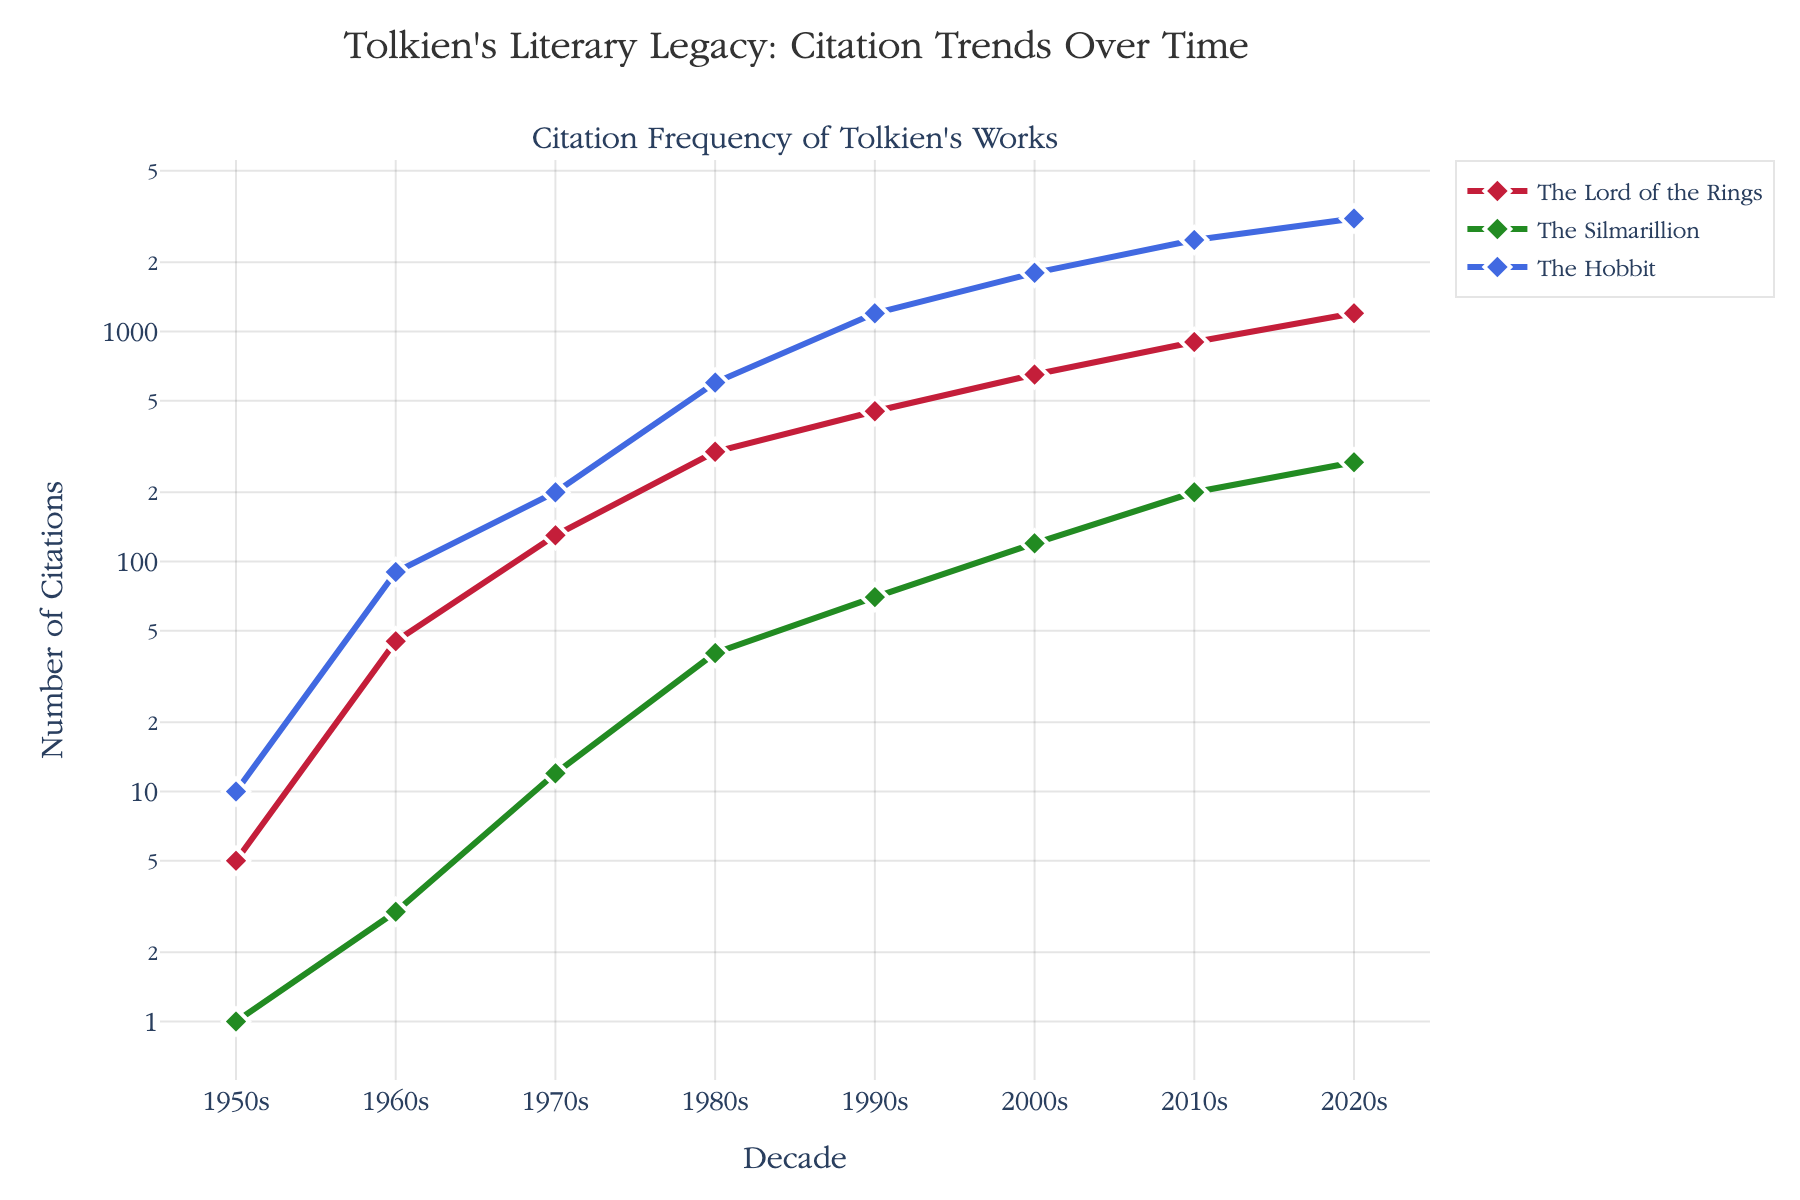What is the title of the figure? The title of the figure is located at the top and is typically set in a larger and bolder font to stand out. In this case, it reads "Citation Frequency of Tolkien's Works".
Answer: Citation Frequency of Tolkien's Works How many distinct works by Tolkien are represented in the figure? Three distinct works are indicated on the legend and are represented by three different colors and labels.
Answer: 3 Which work had the highest number of citations in the 1970s? By examining the y-axis values at the 1970s mark, we see the highest point is for "The Hobbit".
Answer: The Hobbit What is the color representing "The Silmarillion"? The legend specifies the colors for each work. "The Silmarillion" is represented in green.
Answer: Green By how much did the citations for "The Lord of the Rings" increase from the 1950s to the 1980s? The number of citations for "The Lord of the Rings" in the 1950s was 5, and in the 1980s, it was 300. To find the increase, subtract the early value from the later value: 300 - 5 = 295.
Answer: 295 Which decade shows the lowest number of citations for all three works combined? Sum the citations for each work per decade and compare. The 1950s have 5 (LotR) + 1 (Silmarillion) + 10 (Hobbit) = 16, which is the lowest overall sum.
Answer: 1950s In which decade did "The Silmarillion" see the most significant increase in citations? To identify the steepest increase for "The Silmarillion", look for the largest jump between consecutive decades. From the 2000s (120 citations) to the 2010s (200 citations) is the largest increase: 200 - 120 = 80.
Answer: 2000s to 2010s What is the approximate number of citations for "The Hobbit" in the 2020s? Check the y-axis value for "The Hobbit" in the 2020s. It is around 3100 citations, as indicated by the marker.
Answer: 3100 Which work had the smallest relative increase in citations from the 1980s to the 1990s? Calculate the relative increase for each work: LotR (450-300)/300 = 0.5, Silmarillion (70-40)/40 = 0.75, Hobbit (1200-600)/600 = 1.0. "The Lord of the Rings" had the smallest relative increase of 0.5.
Answer: The Lord of the Rings How does the trend for "The Lord of the Rings" citations compare to "The Hobbit" over the entire time span? Both works show an increasing trend, but "The Hobbit" consistently has more citations in each decade. "The Hobbit" starts higher and maintains a larger gap over time.
Answer: The Hobbit consistently more 